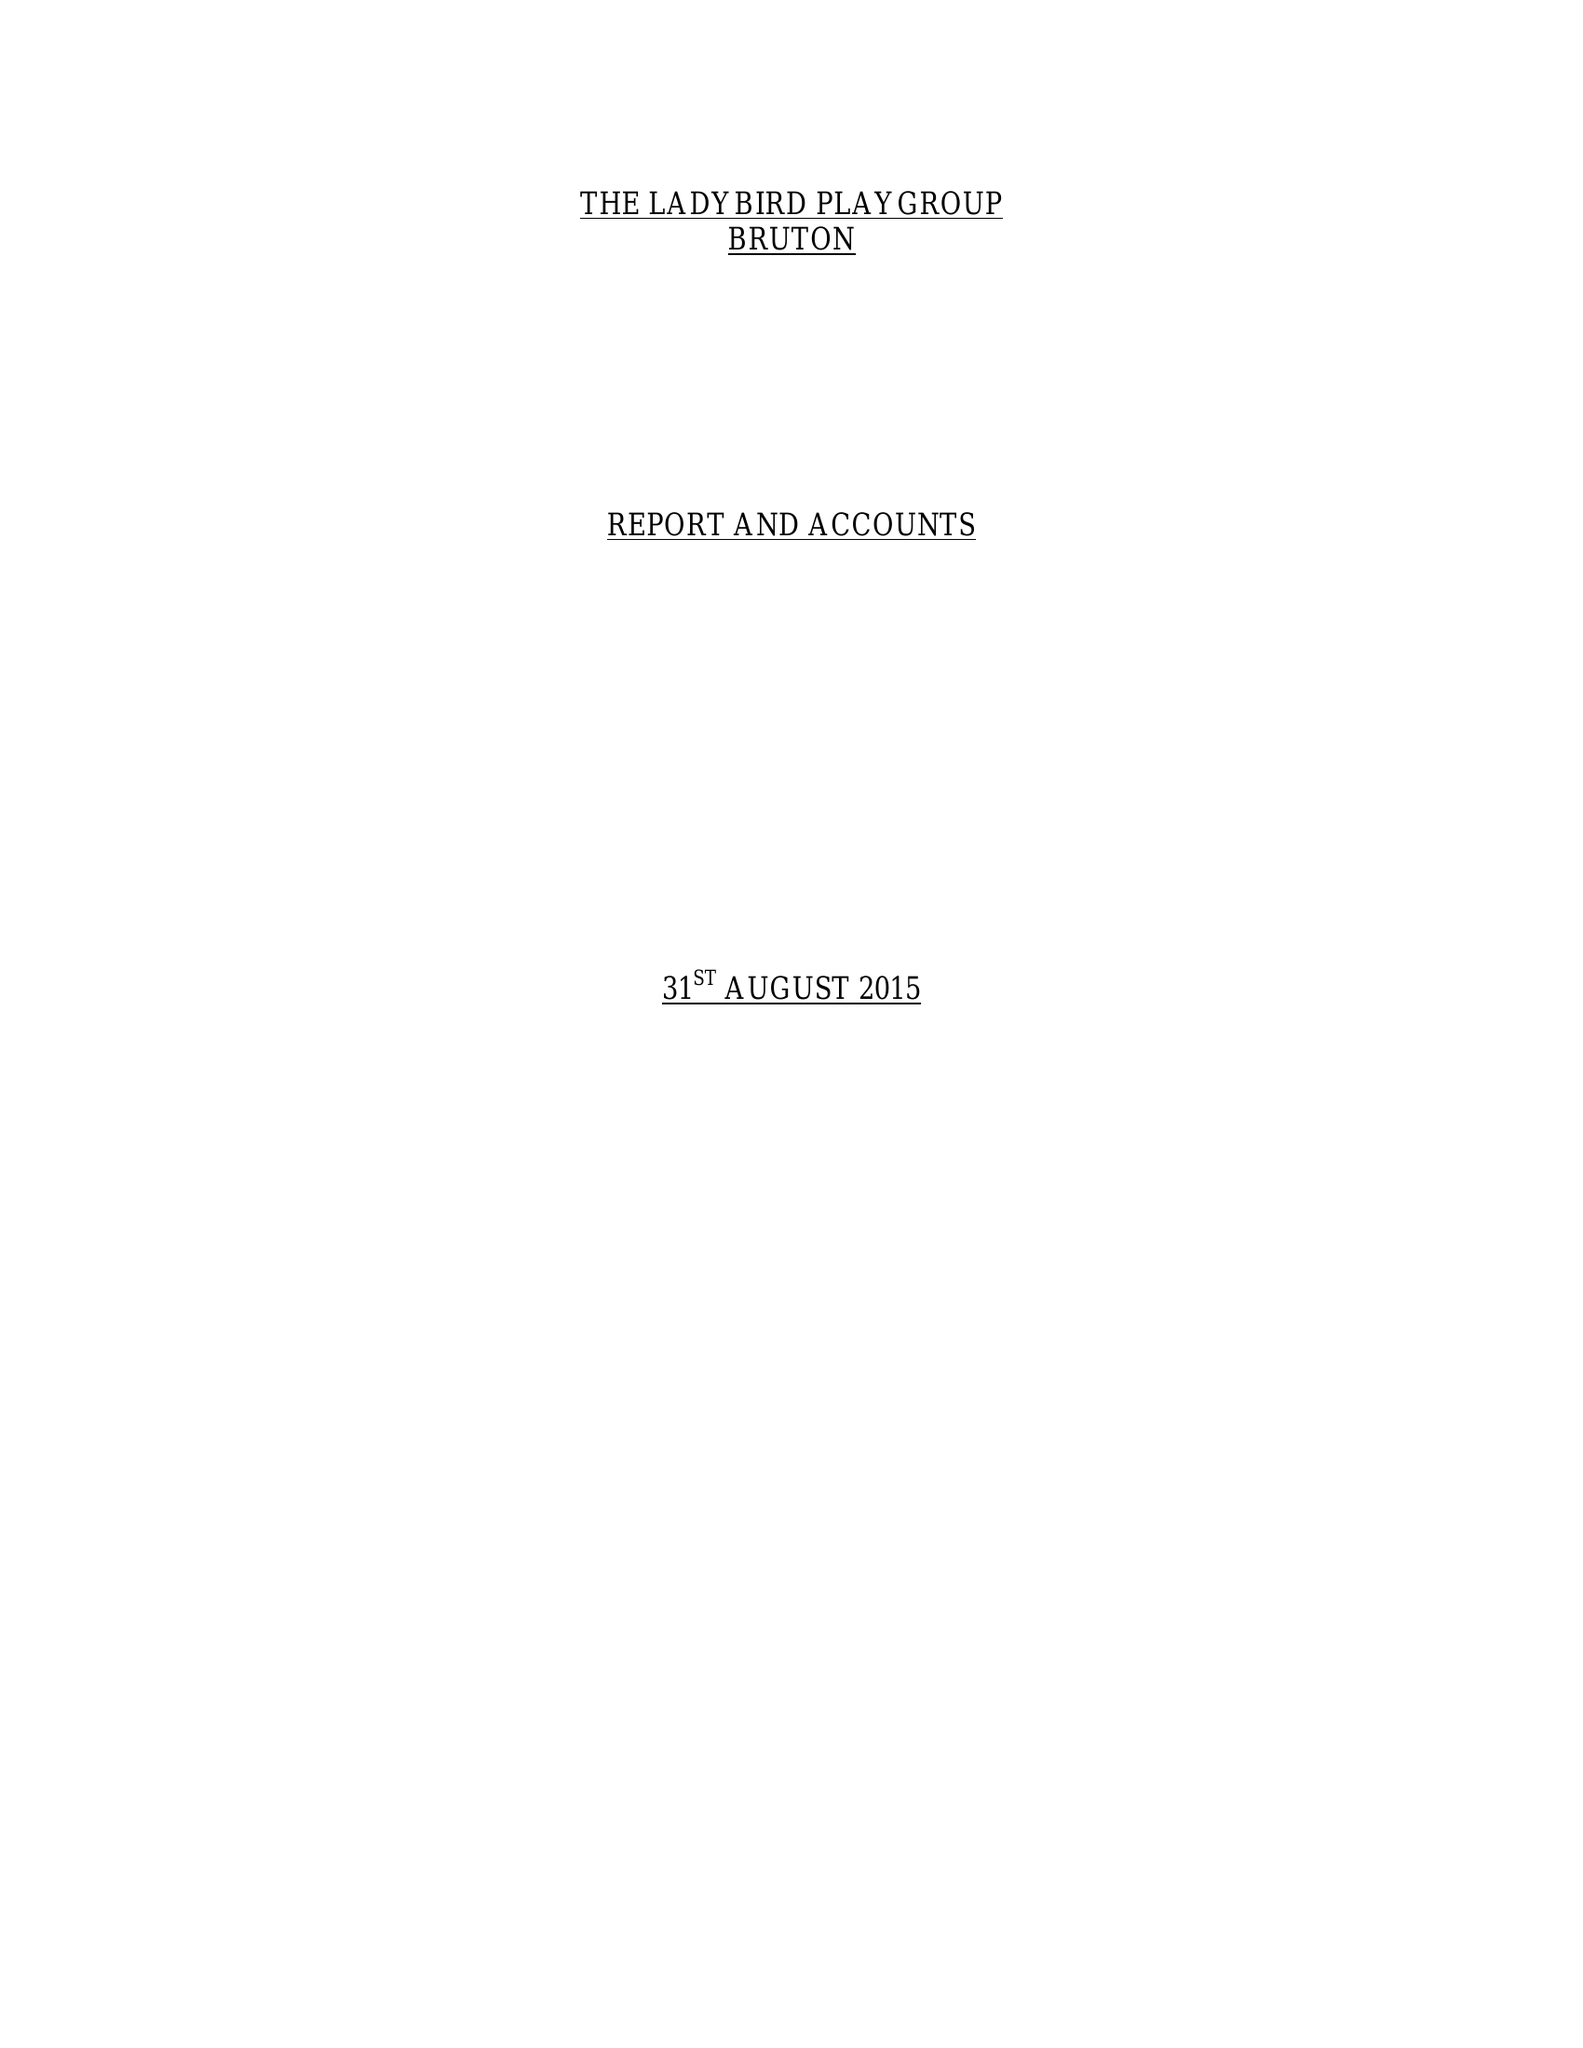What is the value for the address__post_town?
Answer the question using a single word or phrase. BRUTON 